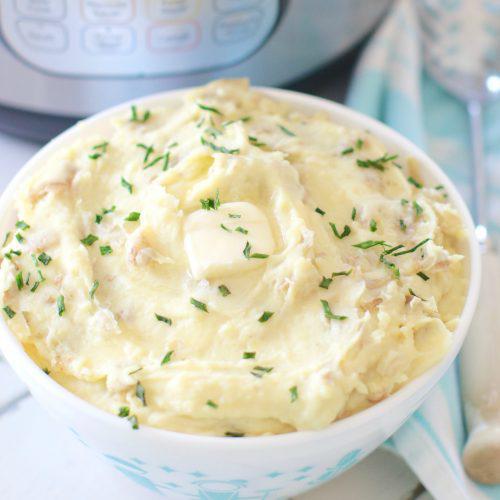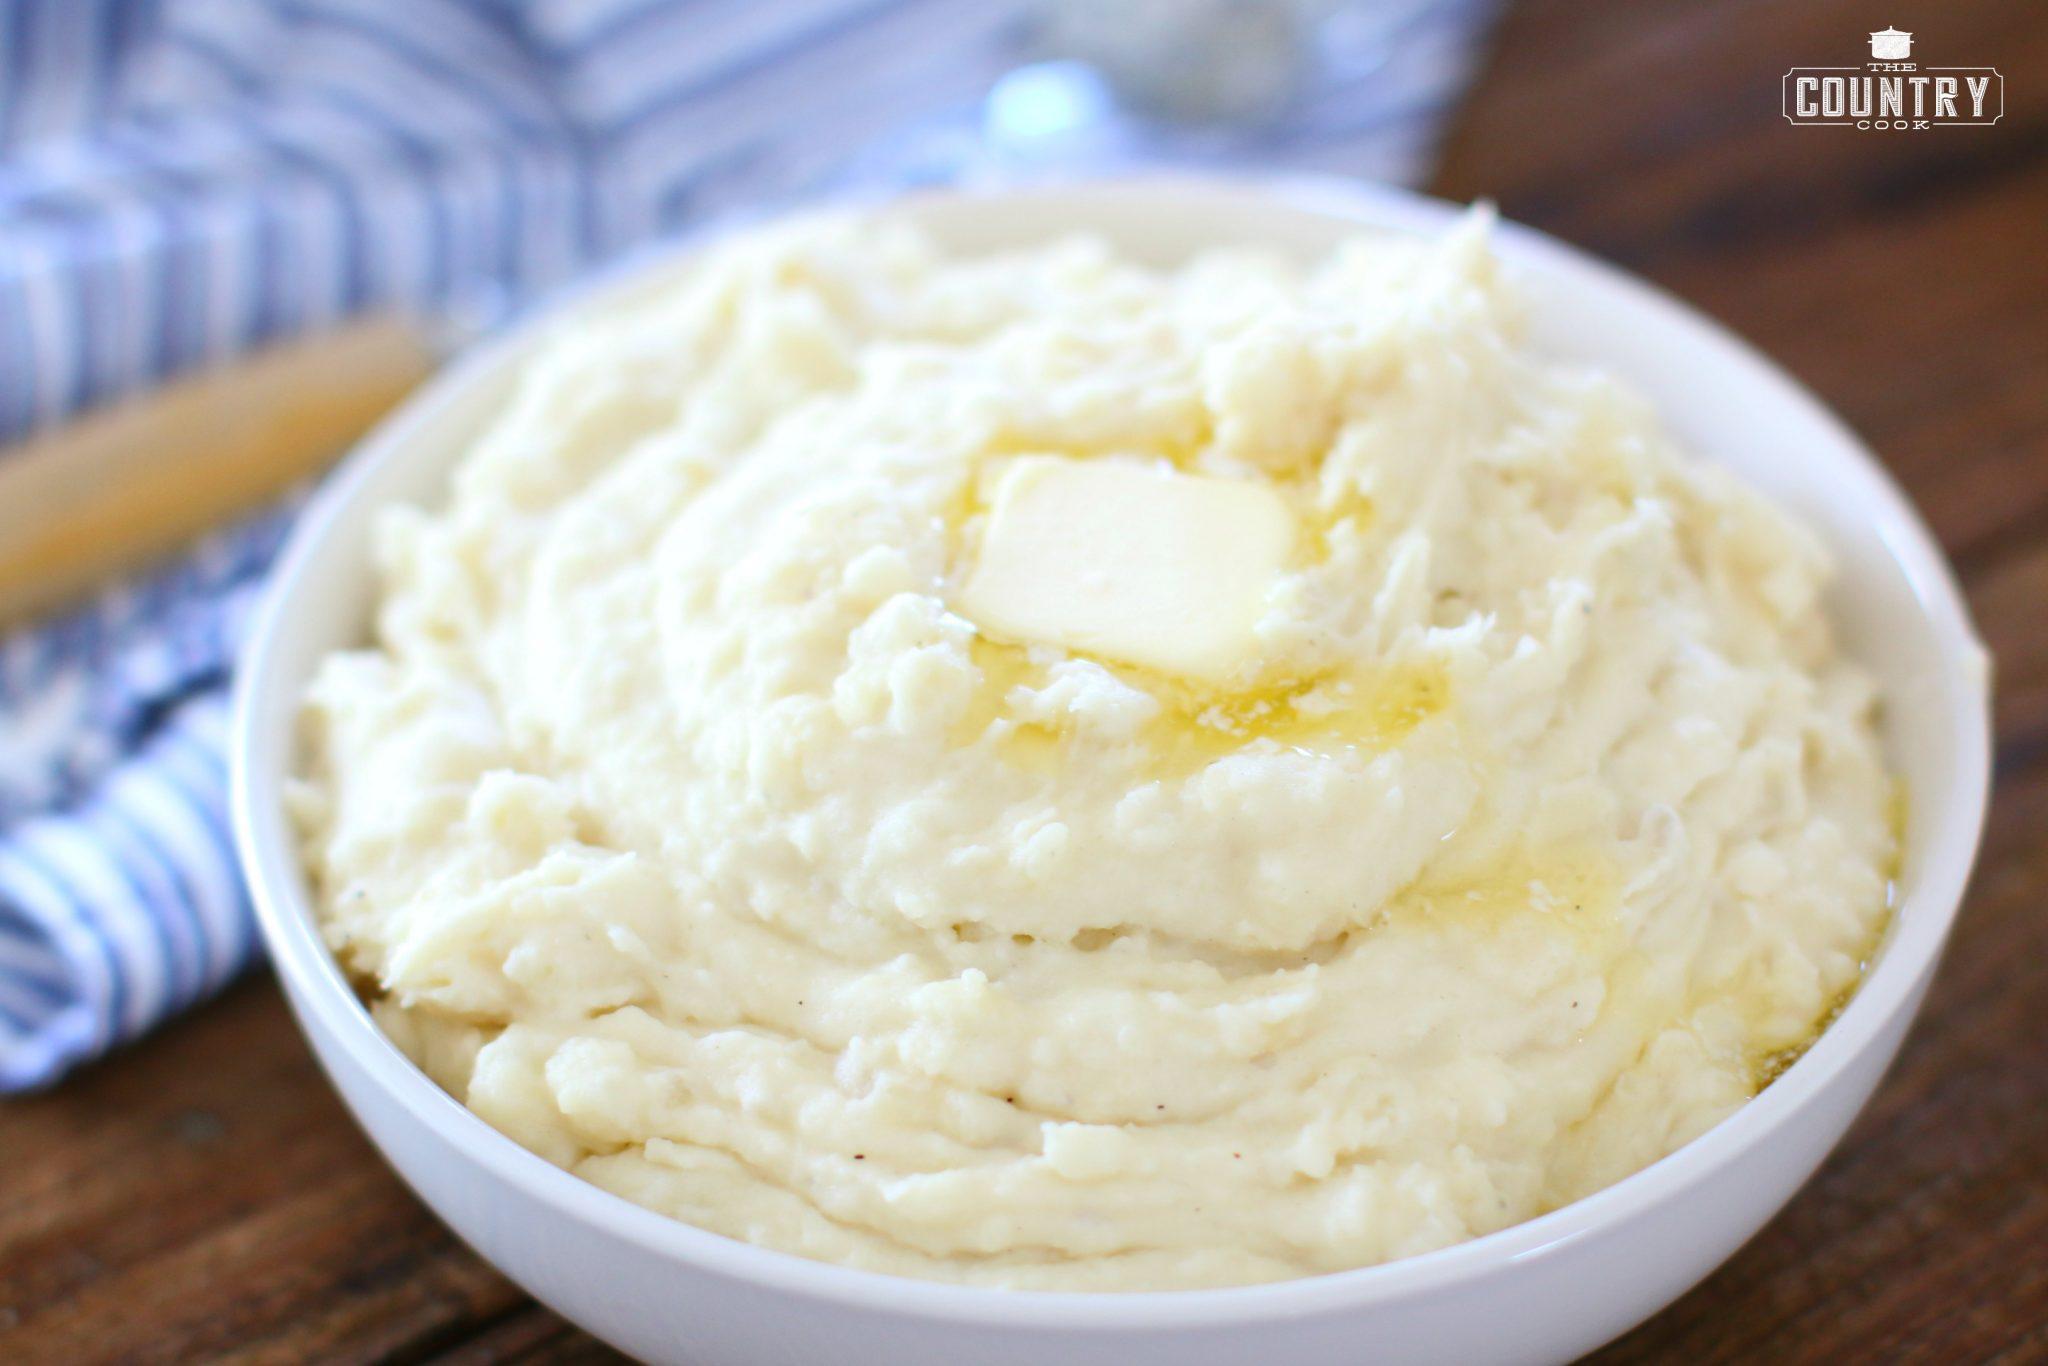The first image is the image on the left, the second image is the image on the right. For the images displayed, is the sentence "The left and right image contains a total of two colored mashed potato bowls." factually correct? Answer yes or no. No. The first image is the image on the left, the second image is the image on the right. Evaluate the accuracy of this statement regarding the images: "The right image includes a round brown bowl with mashed potatoes in it and a spoon.". Is it true? Answer yes or no. No. 